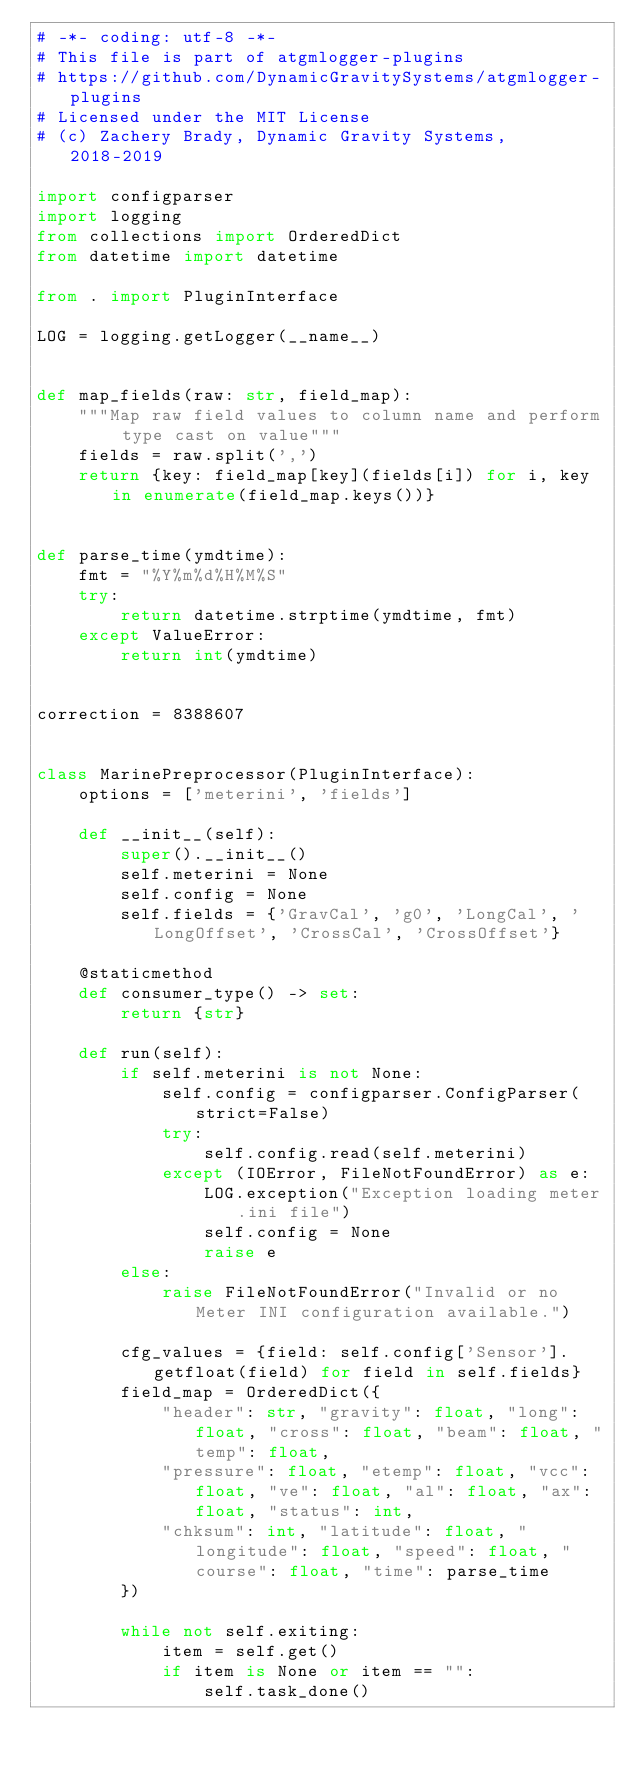Convert code to text. <code><loc_0><loc_0><loc_500><loc_500><_Python_># -*- coding: utf-8 -*-
# This file is part of atgmlogger-plugins
# https://github.com/DynamicGravitySystems/atgmlogger-plugins
# Licensed under the MIT License
# (c) Zachery Brady, Dynamic Gravity Systems, 2018-2019

import configparser
import logging
from collections import OrderedDict
from datetime import datetime

from . import PluginInterface

LOG = logging.getLogger(__name__)


def map_fields(raw: str, field_map):
    """Map raw field values to column name and perform type cast on value"""
    fields = raw.split(',')
    return {key: field_map[key](fields[i]) for i, key in enumerate(field_map.keys())}


def parse_time(ymdtime):
    fmt = "%Y%m%d%H%M%S"
    try:
        return datetime.strptime(ymdtime, fmt)
    except ValueError:
        return int(ymdtime)


correction = 8388607


class MarinePreprocessor(PluginInterface):
    options = ['meterini', 'fields']

    def __init__(self):
        super().__init__()
        self.meterini = None
        self.config = None
        self.fields = {'GravCal', 'g0', 'LongCal', 'LongOffset', 'CrossCal', 'CrossOffset'}

    @staticmethod
    def consumer_type() -> set:
        return {str}

    def run(self):
        if self.meterini is not None:
            self.config = configparser.ConfigParser(strict=False)
            try:
                self.config.read(self.meterini)
            except (IOError, FileNotFoundError) as e:
                LOG.exception("Exception loading meter.ini file")
                self.config = None
                raise e
        else:
            raise FileNotFoundError("Invalid or no Meter INI configuration available.")

        cfg_values = {field: self.config['Sensor'].getfloat(field) for field in self.fields}
        field_map = OrderedDict({
            "header": str, "gravity": float, "long": float, "cross": float, "beam": float, "temp": float,
            "pressure": float, "etemp": float, "vcc": float, "ve": float, "al": float, "ax": float, "status": int,
            "chksum": int, "latitude": float, "longitude": float, "speed": float, "course": float, "time": parse_time
        })

        while not self.exiting:
            item = self.get()
            if item is None or item == "":
                self.task_done()</code> 